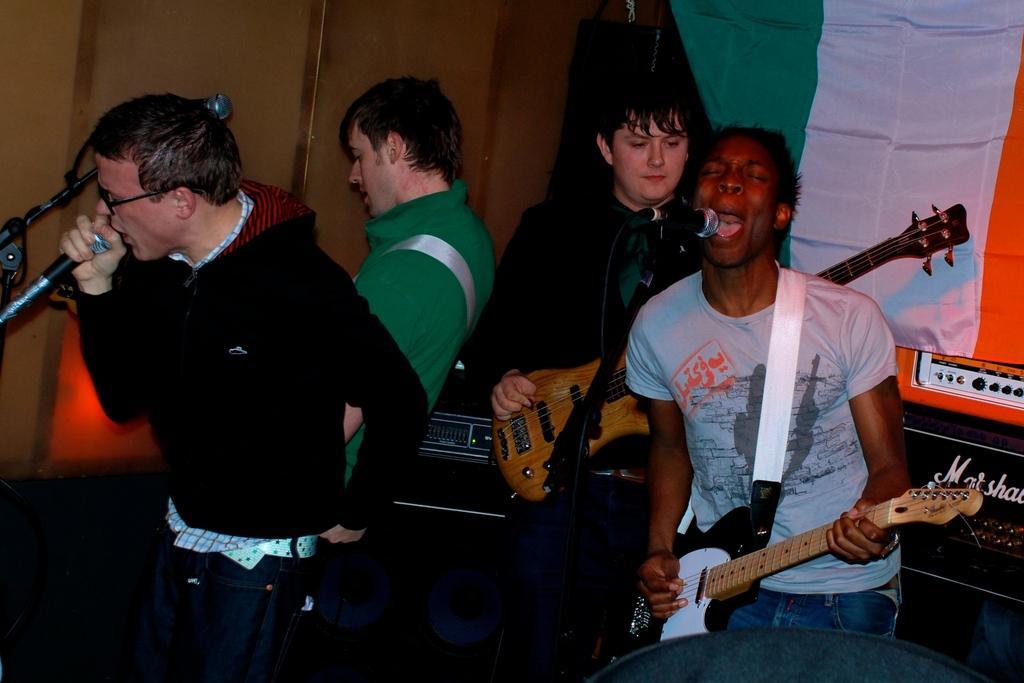Describe this image in one or two sentences. In the picture there are four persons performing some music and singing along in the left corner the person wearing a black jacket is holding a mic in his hand and singing he has a glasses. In the right the person is wearing a grey t shirt holding a guitar in his hand and singing along in front of him there is mic and in the back ground there are two persons holding a guitar one is dressed in black the other is dressed in green in the right corner of the picture there is flag colored green white and orange and there is some musical instruments to the right corner. In the left corner background there is wooden plank in brown in color. 